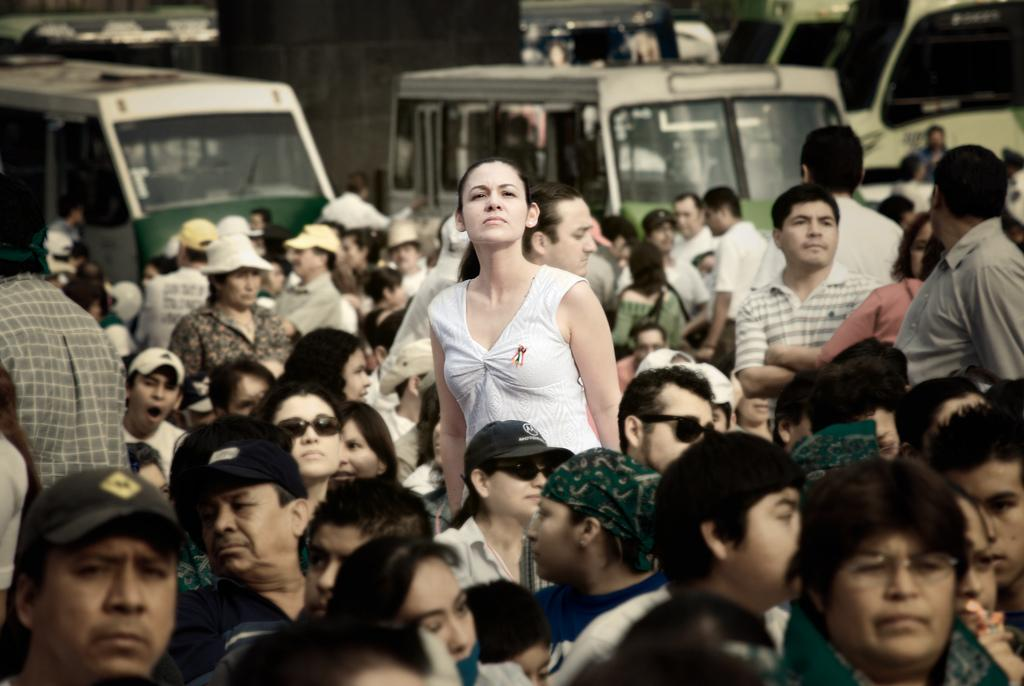How many people are in the image? There is a group of people in the image, but the exact number is not specified. What can be seen in the background of the image? Vehicles are visible in the background of the image. How many horses are present in the image? There are no horses visible in the image. What type of string is being used by the people in the image? There is no mention of string or any related activity in the image. 